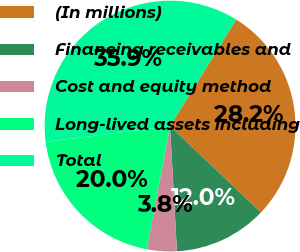Convert chart. <chart><loc_0><loc_0><loc_500><loc_500><pie_chart><fcel>(In millions)<fcel>Financing receivables and<fcel>Cost and equity method<fcel>Long-lived assets including<fcel>Total<nl><fcel>28.24%<fcel>12.03%<fcel>3.85%<fcel>20.0%<fcel>35.88%<nl></chart> 